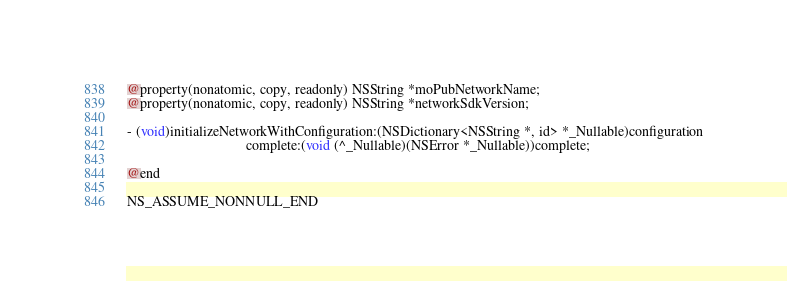Convert code to text. <code><loc_0><loc_0><loc_500><loc_500><_C_>@property(nonatomic, copy, readonly) NSString *moPubNetworkName;
@property(nonatomic, copy, readonly) NSString *networkSdkVersion;

- (void)initializeNetworkWithConfiguration:(NSDictionary<NSString *, id> *_Nullable)configuration
                                  complete:(void (^_Nullable)(NSError *_Nullable))complete;

@end

NS_ASSUME_NONNULL_END
</code> 